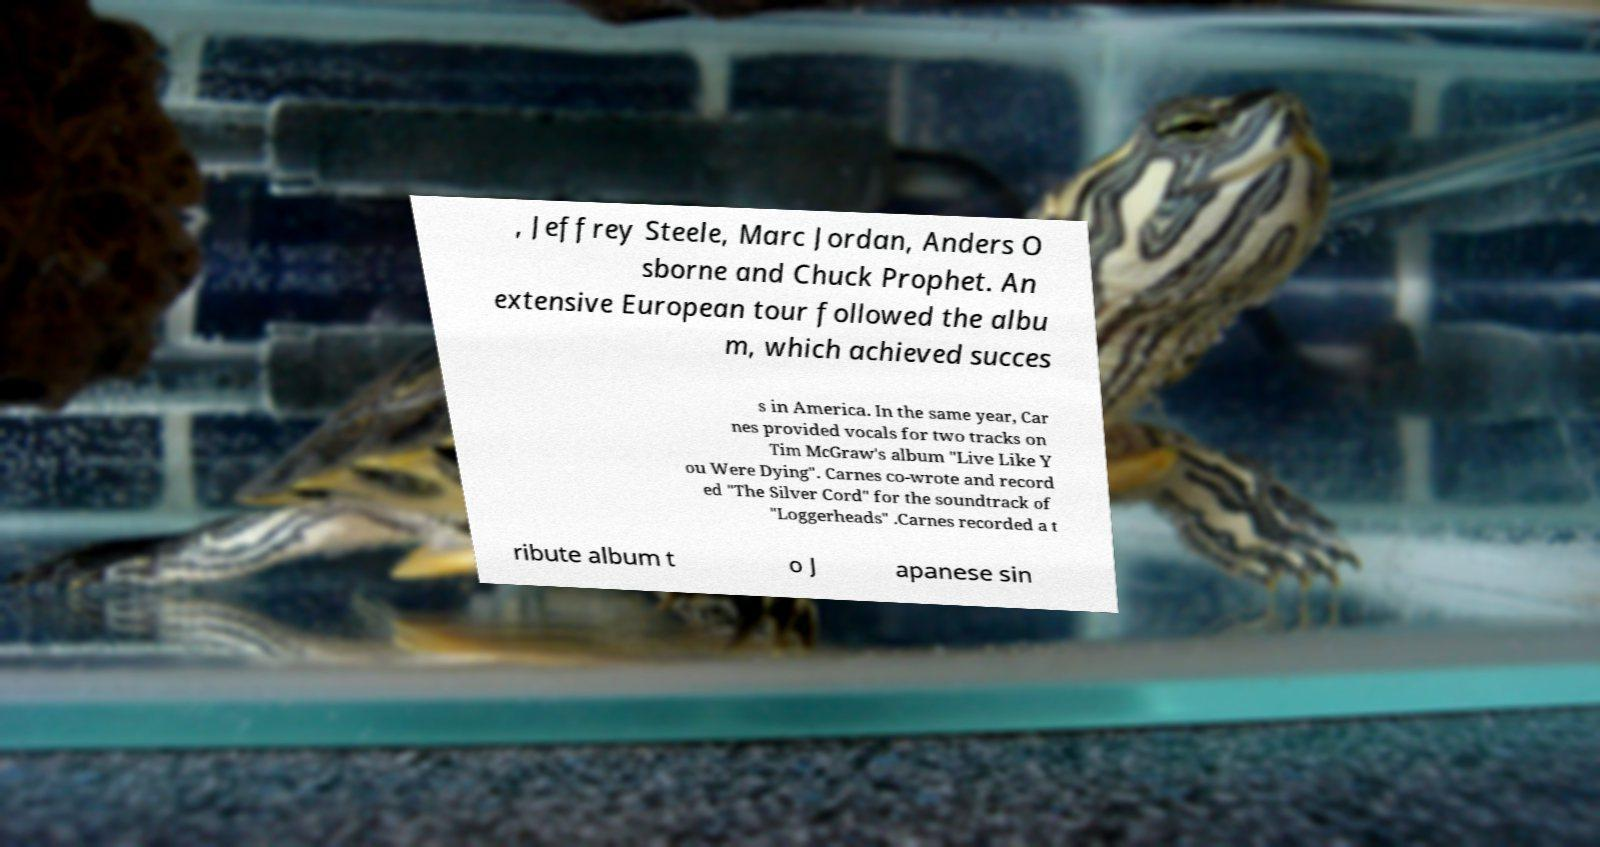Could you extract and type out the text from this image? , Jeffrey Steele, Marc Jordan, Anders O sborne and Chuck Prophet. An extensive European tour followed the albu m, which achieved succes s in America. In the same year, Car nes provided vocals for two tracks on Tim McGraw's album "Live Like Y ou Were Dying". Carnes co-wrote and record ed "The Silver Cord" for the soundtrack of "Loggerheads" .Carnes recorded a t ribute album t o J apanese sin 